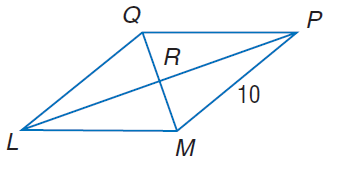Answer the mathemtical geometry problem and directly provide the correct option letter.
Question: In rhombus L M P Q, m \angle Q L M = 2 x^ { 2 } - 10, m \angle Q P M = 8 x, and M P = 10. Find m \angle L Q M.
Choices: A: 10 B: 20 C: 70 D: 80 C 